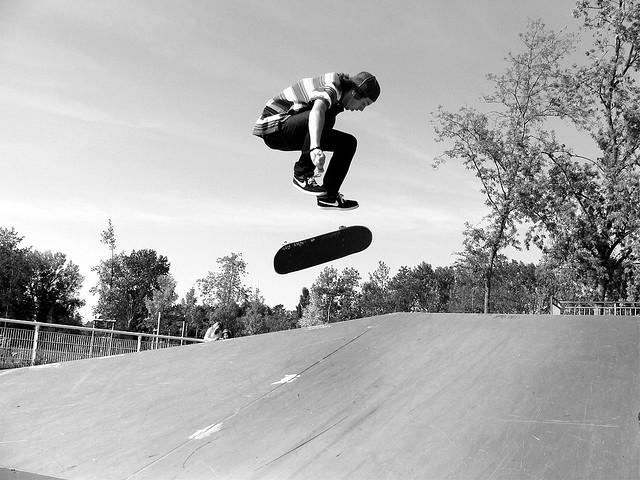What kind of shoes is the skater wearing? nike 